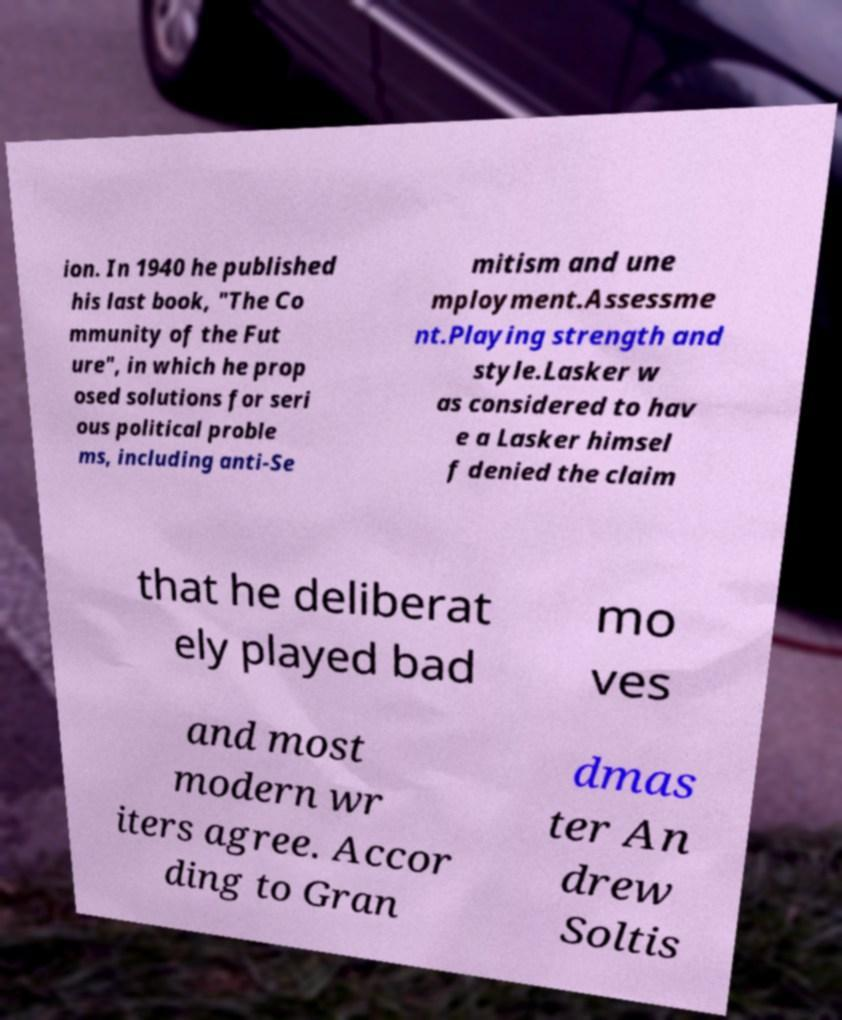Can you read and provide the text displayed in the image?This photo seems to have some interesting text. Can you extract and type it out for me? ion. In 1940 he published his last book, "The Co mmunity of the Fut ure", in which he prop osed solutions for seri ous political proble ms, including anti-Se mitism and une mployment.Assessme nt.Playing strength and style.Lasker w as considered to hav e a Lasker himsel f denied the claim that he deliberat ely played bad mo ves and most modern wr iters agree. Accor ding to Gran dmas ter An drew Soltis 